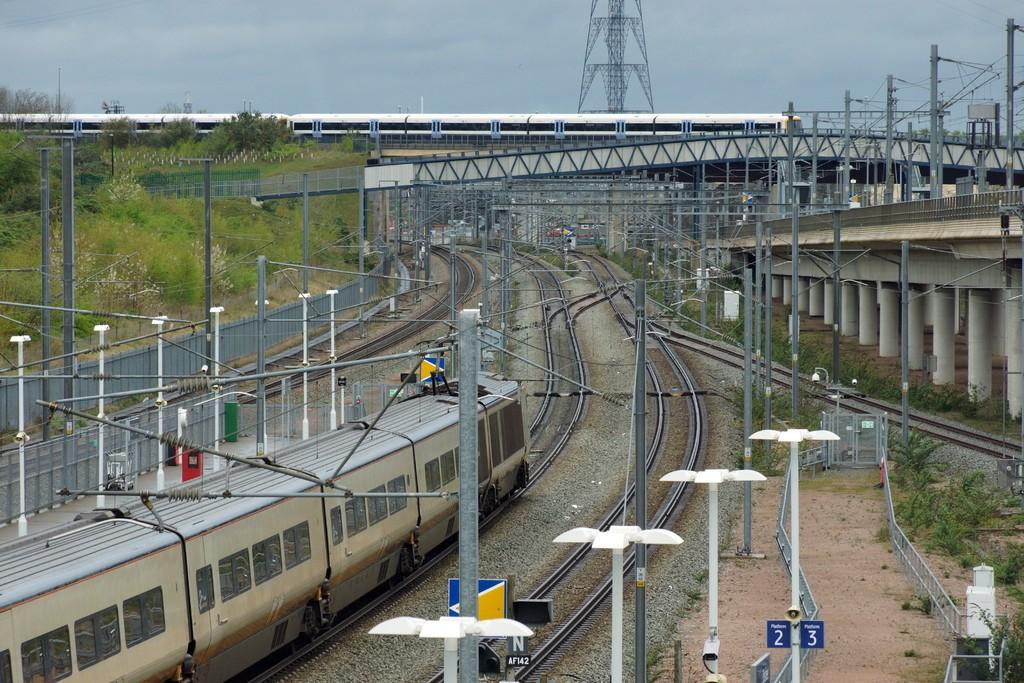Provide a one-sentence caption for the provided image. Train tracks in a train yard with platform 2 and platform 3. 